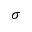Convert formula to latex. <formula><loc_0><loc_0><loc_500><loc_500>{ \sigma }</formula> 